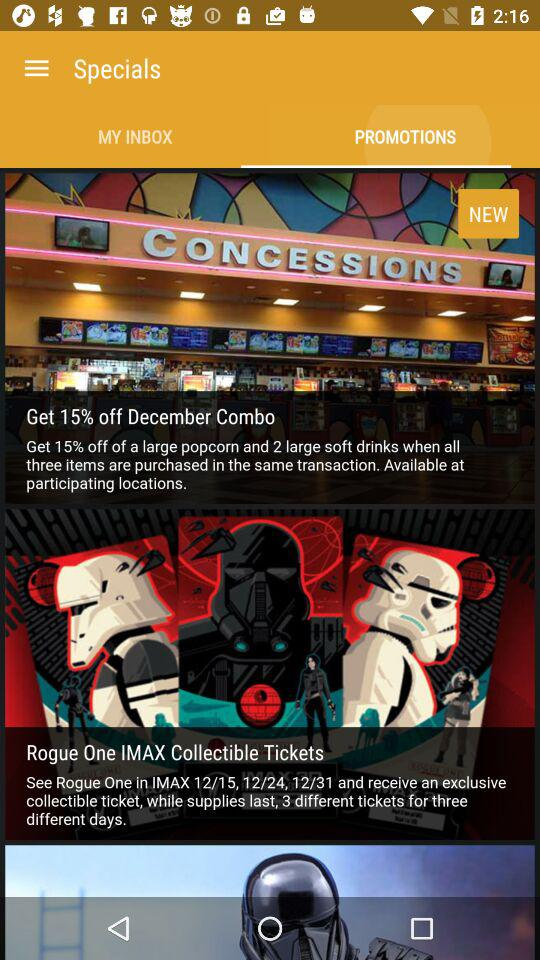How many days are there in the Rogue One IMAX Collectible Tickets offer?
Answer the question using a single word or phrase. 3 